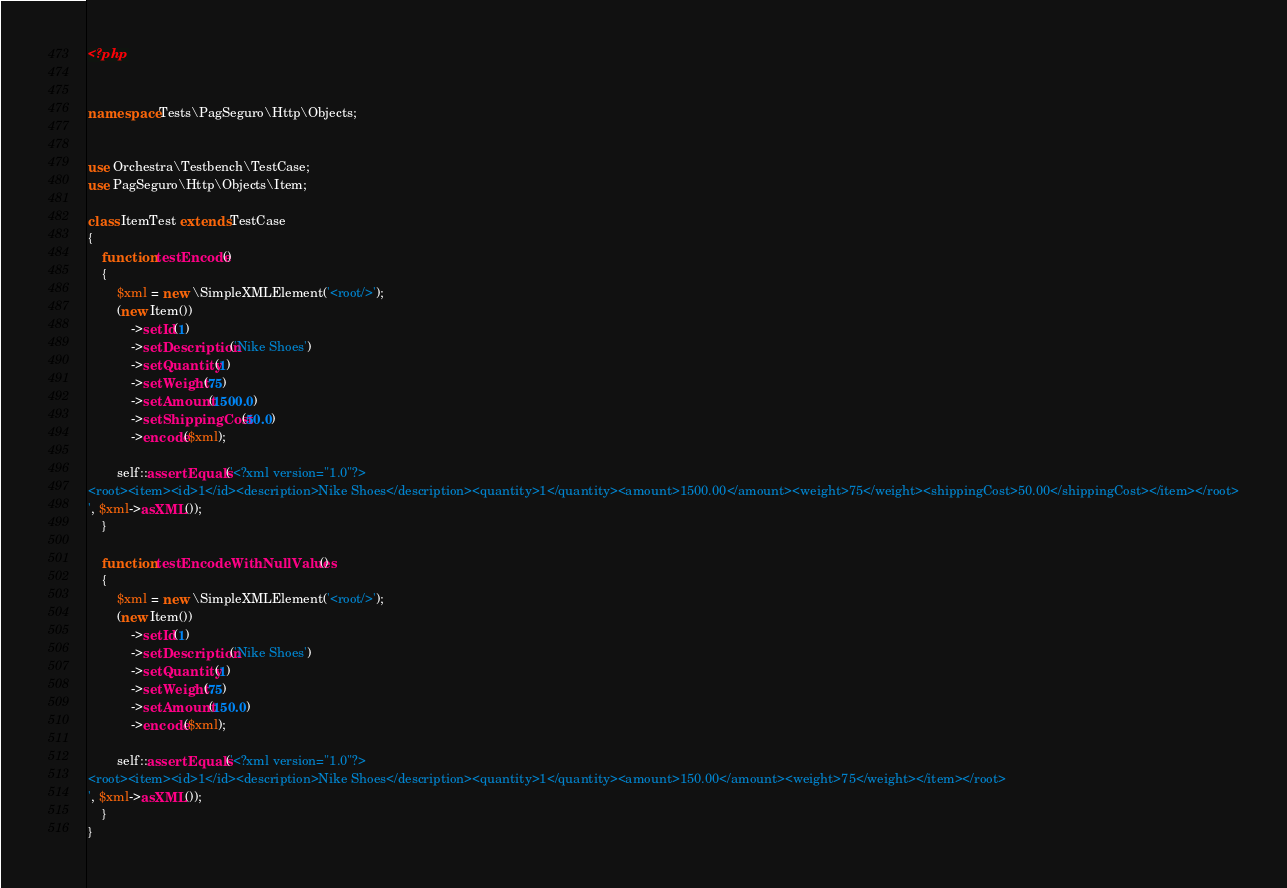Convert code to text. <code><loc_0><loc_0><loc_500><loc_500><_PHP_><?php


namespace Tests\PagSeguro\Http\Objects;


use Orchestra\Testbench\TestCase;
use PagSeguro\Http\Objects\Item;

class ItemTest extends TestCase
{
    function testEncode()
    {
        $xml = new \SimpleXMLElement('<root/>');
        (new Item())
            ->setId(1)
            ->setDescription('Nike Shoes')
            ->setQuantity(1)
            ->setWeight(75)
            ->setAmount(1500.0)
            ->setShippingCost(50.0)
            ->encode($xml);

        self::assertEquals('<?xml version="1.0"?>
<root><item><id>1</id><description>Nike Shoes</description><quantity>1</quantity><amount>1500.00</amount><weight>75</weight><shippingCost>50.00</shippingCost></item></root>
', $xml->asXML());
    }

    function testEncodeWithNullValues()
    {
        $xml = new \SimpleXMLElement('<root/>');
        (new Item())
            ->setId(1)
            ->setDescription('Nike Shoes')
            ->setQuantity(1)
            ->setWeight(75)
            ->setAmount(150.0)
            ->encode($xml);

        self::assertEquals('<?xml version="1.0"?>
<root><item><id>1</id><description>Nike Shoes</description><quantity>1</quantity><amount>150.00</amount><weight>75</weight></item></root>
', $xml->asXML());
    }
}</code> 